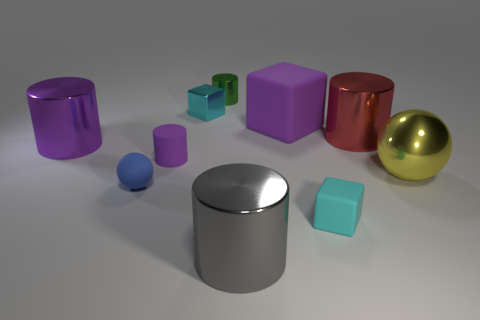Subtract all gray shiny cylinders. How many cylinders are left? 4 Subtract all gray cylinders. How many cylinders are left? 4 Subtract 2 cylinders. How many cylinders are left? 3 Subtract all yellow cylinders. Subtract all blue blocks. How many cylinders are left? 5 Subtract all cubes. How many objects are left? 7 Subtract all small blue matte objects. Subtract all gray shiny objects. How many objects are left? 8 Add 5 yellow metal objects. How many yellow metal objects are left? 6 Add 2 small cyan objects. How many small cyan objects exist? 4 Subtract 0 yellow blocks. How many objects are left? 10 